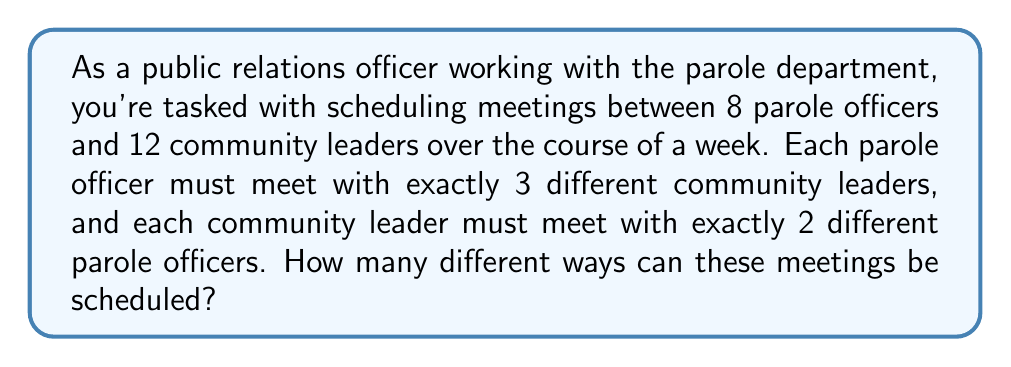Show me your answer to this math problem. To solve this problem, we'll use the concept of permutations with restrictions. Let's break it down step-by-step:

1) First, we need to consider the total number of meetings:
   8 parole officers × 3 meetings each = 24 total meetings
   This matches 12 community leaders × 2 meetings each = 24 total meetings

2) We can represent this schedule as a list of 24 pairs, where each pair consists of a parole officer and a community leader.

3) For the first pair, we have 8 choices for the parole officer and 12 choices for the community leader. This gives us 8 × 12 = 96 possibilities for the first pair.

4) For the second pair, we have 8 choices for the parole officer (because they can meet multiple times, just not with the same community leader) and 11 choices for the community leader (because one has already been chosen).

5) This pattern continues, but with additional restrictions:
   - Each parole officer can only appear 3 times in the list
   - Each community leader can only appear 2 times in the list

6) The total number of permutations can be expressed as:

   $$(8 \times 12) \times (8 \times 11) \times (8 \times 10) \times ... \times (1 \times 1)$$

   However, this overcounts because it doesn't account for the restrictions.

7) To account for the restrictions, we need to divide by the number of ways to arrange each parole officer's 3 meetings and each community leader's 2 meetings:

   $$\frac{(8 \times 12) \times (8 \times 11) \times (8 \times 10) \times ... \times (1 \times 1)}{(3!)^8 \times (2!)^{12}}$$

8) This can be simplified to:

   $$\frac{24!}{(3!)^8 \times (2!)^{12}}$$

9) Calculating this:
   $24! = 6.2045 \times 10^{23}$
   $(3!)^8 = 6^8 = 1,679,616$
   $(2!)^{12} = 2^{12} = 4,096$
   
   $$\frac{6.2045 \times 10^{23}}{1,679,616 \times 4,096} \approx 9.0325 \times 10^{13}$$
Answer: There are approximately $9.0325 \times 10^{13}$ different ways to schedule these meetings. 